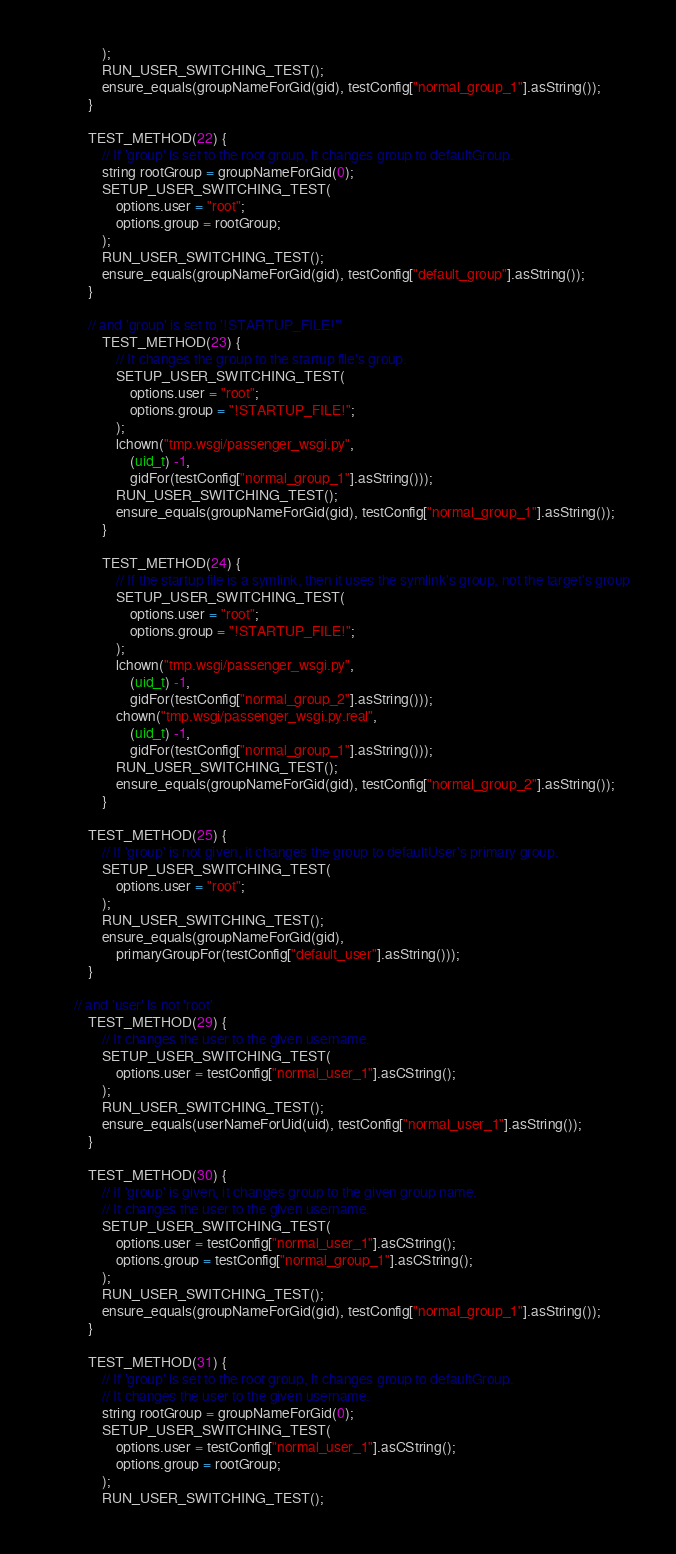Convert code to text. <code><loc_0><loc_0><loc_500><loc_500><_C++_>				);
				RUN_USER_SWITCHING_TEST();
				ensure_equals(groupNameForGid(gid), testConfig["normal_group_1"].asString());
			}

			TEST_METHOD(22) {
				// If 'group' is set to the root group, it changes group to defaultGroup.
				string rootGroup = groupNameForGid(0);
				SETUP_USER_SWITCHING_TEST(
					options.user = "root";
					options.group = rootGroup;
				);
				RUN_USER_SWITCHING_TEST();
				ensure_equals(groupNameForGid(gid), testConfig["default_group"].asString());
			}

			// and 'group' is set to '!STARTUP_FILE!'"
				TEST_METHOD(23) {
					// It changes the group to the startup file's group.
					SETUP_USER_SWITCHING_TEST(
						options.user = "root";
						options.group = "!STARTUP_FILE!";
					);
					lchown("tmp.wsgi/passenger_wsgi.py",
						(uid_t) -1,
						gidFor(testConfig["normal_group_1"].asString()));
					RUN_USER_SWITCHING_TEST();
					ensure_equals(groupNameForGid(gid), testConfig["normal_group_1"].asString());
				}

				TEST_METHOD(24) {
					// If the startup file is a symlink, then it uses the symlink's group, not the target's group
					SETUP_USER_SWITCHING_TEST(
						options.user = "root";
						options.group = "!STARTUP_FILE!";
					);
					lchown("tmp.wsgi/passenger_wsgi.py",
						(uid_t) -1,
						gidFor(testConfig["normal_group_2"].asString()));
					chown("tmp.wsgi/passenger_wsgi.py.real",
						(uid_t) -1,
						gidFor(testConfig["normal_group_1"].asString()));
					RUN_USER_SWITCHING_TEST();
					ensure_equals(groupNameForGid(gid), testConfig["normal_group_2"].asString());
				}

			TEST_METHOD(25) {
				// If 'group' is not given, it changes the group to defaultUser's primary group.
				SETUP_USER_SWITCHING_TEST(
					options.user = "root";
				);
				RUN_USER_SWITCHING_TEST();
				ensure_equals(groupNameForGid(gid),
					primaryGroupFor(testConfig["default_user"].asString()));
			}

		// and 'user' is not 'root'
			TEST_METHOD(29) {
				// It changes the user to the given username.
				SETUP_USER_SWITCHING_TEST(
					options.user = testConfig["normal_user_1"].asCString();
				);
				RUN_USER_SWITCHING_TEST();
				ensure_equals(userNameForUid(uid), testConfig["normal_user_1"].asString());
			}

			TEST_METHOD(30) {
				// If 'group' is given, it changes group to the given group name.
				// It changes the user to the given username.
				SETUP_USER_SWITCHING_TEST(
					options.user = testConfig["normal_user_1"].asCString();
					options.group = testConfig["normal_group_1"].asCString();
				);
				RUN_USER_SWITCHING_TEST();
				ensure_equals(groupNameForGid(gid), testConfig["normal_group_1"].asString());
			}

			TEST_METHOD(31) {
				// If 'group' is set to the root group, it changes group to defaultGroup.
				// It changes the user to the given username.
				string rootGroup = groupNameForGid(0);
				SETUP_USER_SWITCHING_TEST(
					options.user = testConfig["normal_user_1"].asCString();
					options.group = rootGroup;
				);
				RUN_USER_SWITCHING_TEST();</code> 